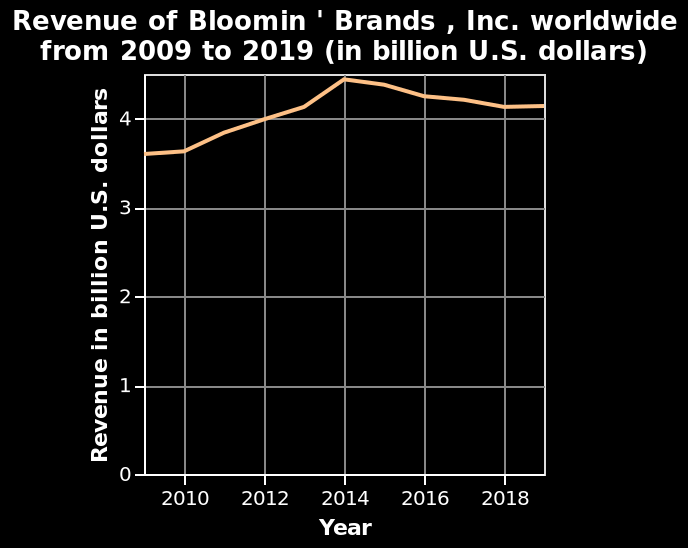<image>
please summary the statistics and relations of the chart The revenue of blooming brands was increasing between 2008 and 2014. In 2014 the revenue started slowly decreasing by about 0.5 billion every 2 years. 